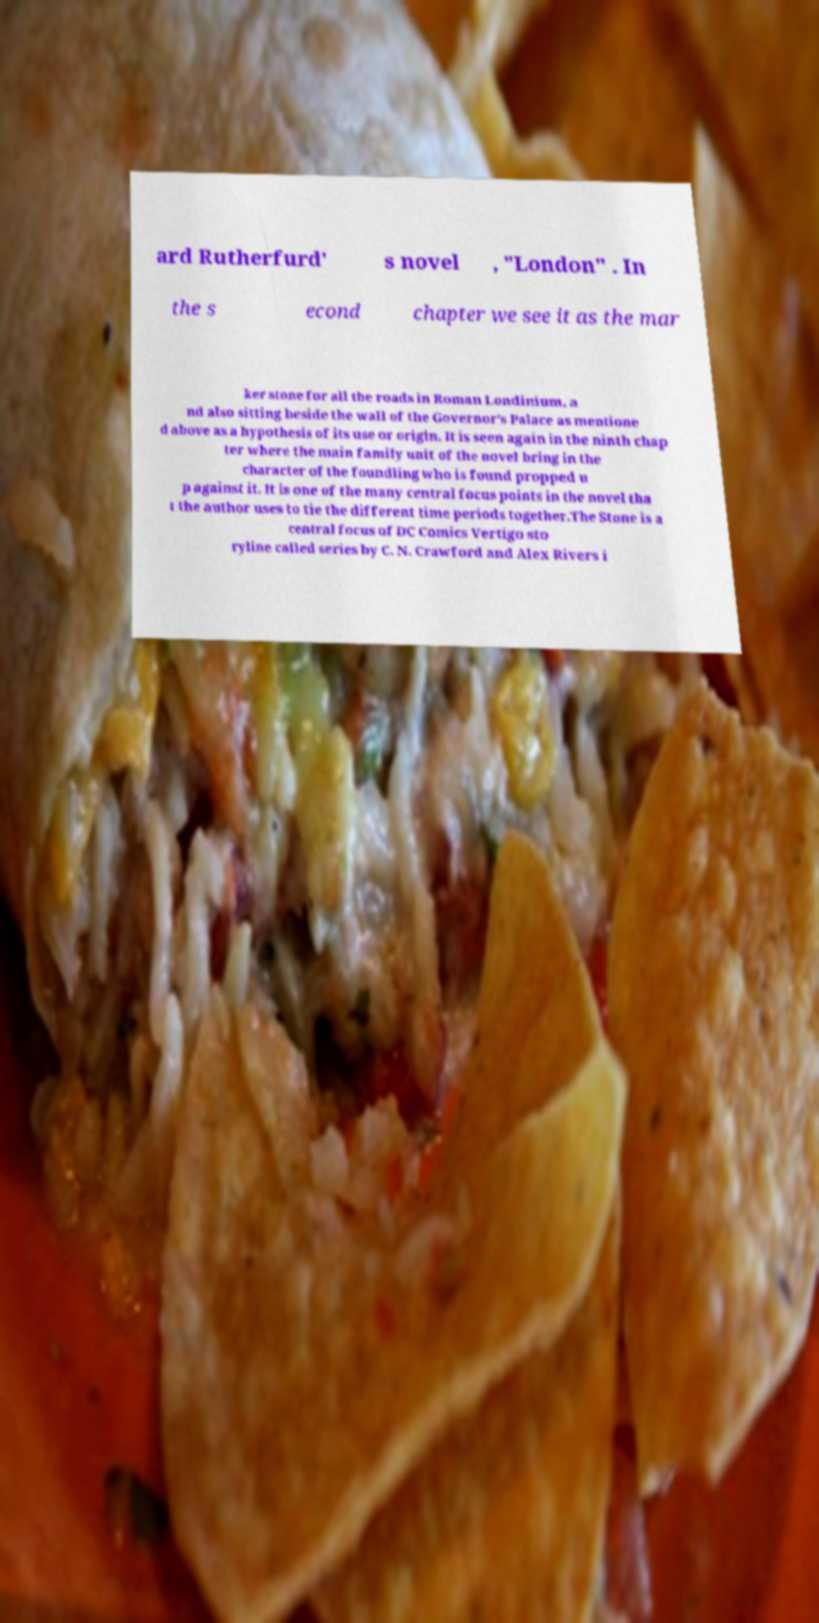What messages or text are displayed in this image? I need them in a readable, typed format. ard Rutherfurd' s novel , "London" . In the s econd chapter we see it as the mar ker stone for all the roads in Roman Londinium, a nd also sitting beside the wall of the Governor's Palace as mentione d above as a hypothesis of its use or origin. It is seen again in the ninth chap ter where the main family unit of the novel bring in the character of the foundling who is found propped u p against it. It is one of the many central focus points in the novel tha t the author uses to tie the different time periods together.The Stone is a central focus of DC Comics Vertigo sto ryline called series by C. N. Crawford and Alex Rivers i 